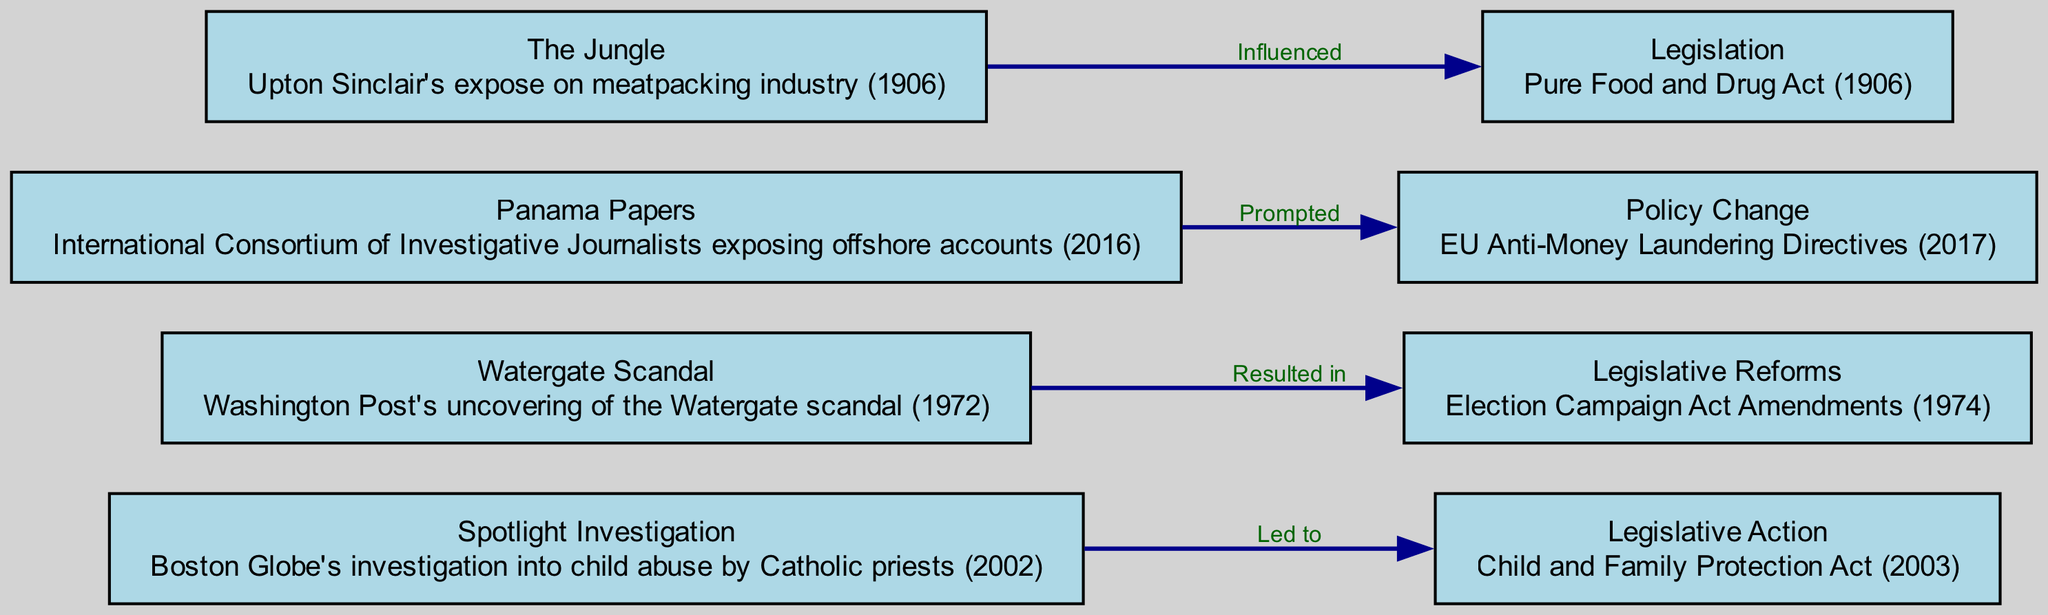What is the first investigated topic in the timeline? The first topic listed in the diagram is "Upton Sinclair's expose on meatpacking industry," which was published in 1906. This is confirmed by examining the nodes in the diagram where "The Jungle" is the first point.
Answer: The Jungle Which investigation led to the Child and Family Protection Act? The diagram indicates that the "Spotlight Investigation" is connected to the "Child and Family Protection Act," showing that this investigative report led to the legislative action in 2003.
Answer: Spotlight Investigation How many significant investigative reports are highlighted in the diagram? The diagram lists four significant investigative reports, each represented as a node. Counting these reveals that there are four reports: "The Jungle," "Watergate Scandal," "Spotlight Investigation," and "Panama Papers."
Answer: 4 What legislative action resulted from the Panama Papers investigation? According to the diagram, the investigation into the Panama Papers led to the EU Anti-Money Laundering Directives, depicting a direct connection from one node to another.
Answer: EU Anti-Money Laundering Directives Which legislative reforms followed the Watergate scandal? The edge in the diagram points from the "Watergate Scandal" to "Election Campaign Act Amendments," indicating this legislative reform directly resulted from the investigation.
Answer: Election Campaign Act Amendments What is the connection between The Jungle and Pure Food and Drug Act? The diagram indicates that "The Jungle" influenced the "Pure Food and Drug Act," showing the relationship in the edge connecting these two nodes.
Answer: Influenced Which year did the Child and Family Protection Act pass? The diagram provides the description for the legislative action as occurring in 2003, thus directly indicating the year of its passage.
Answer: 2003 What is the most recent investigative report listed? The Panama Papers investigation, described as occurring in 2016, is the most recent entry in the timeline of significant investigative reports.
Answer: Panama Papers 